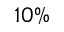<formula> <loc_0><loc_0><loc_500><loc_500>1 0 \%</formula> 